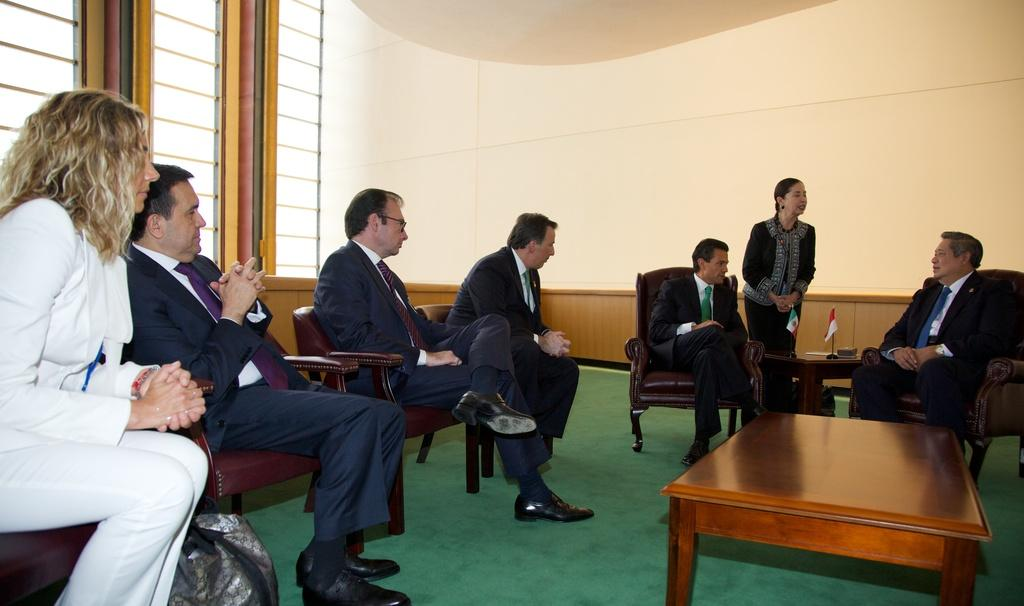How many people are in the image? There is a group of people in the image. What are some of the people doing in the image? Some people are sitting on a couch, and some are sitting on a chair. What can be seen in the background of the image? There is a table, a flag, a wall, and a window in the background of the image. What type of cave is visible in the background of the image? There is no cave present in the image; it features a group of people sitting on a couch and chair, with a table, flag, wall, and window in the background. 